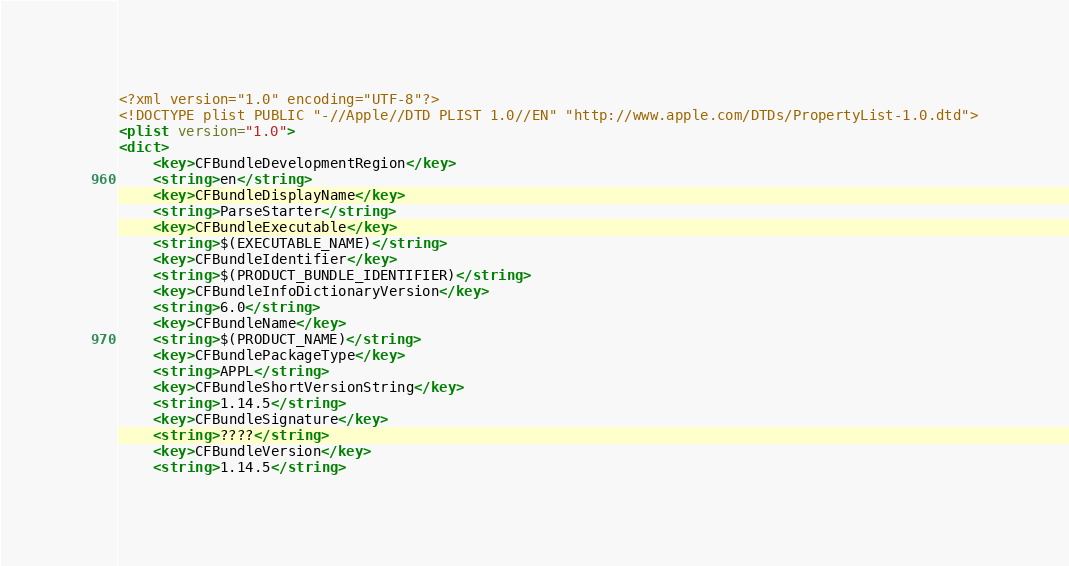Convert code to text. <code><loc_0><loc_0><loc_500><loc_500><_XML_><?xml version="1.0" encoding="UTF-8"?>
<!DOCTYPE plist PUBLIC "-//Apple//DTD PLIST 1.0//EN" "http://www.apple.com/DTDs/PropertyList-1.0.dtd">
<plist version="1.0">
<dict>
	<key>CFBundleDevelopmentRegion</key>
	<string>en</string>
	<key>CFBundleDisplayName</key>
	<string>ParseStarter</string>
	<key>CFBundleExecutable</key>
	<string>$(EXECUTABLE_NAME)</string>
	<key>CFBundleIdentifier</key>
	<string>$(PRODUCT_BUNDLE_IDENTIFIER)</string>
	<key>CFBundleInfoDictionaryVersion</key>
	<string>6.0</string>
	<key>CFBundleName</key>
	<string>$(PRODUCT_NAME)</string>
	<key>CFBundlePackageType</key>
	<string>APPL</string>
	<key>CFBundleShortVersionString</key>
	<string>1.14.5</string>
	<key>CFBundleSignature</key>
	<string>????</string>
	<key>CFBundleVersion</key>
	<string>1.14.5</string></code> 